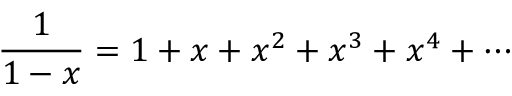Convert formula to latex. <formula><loc_0><loc_0><loc_500><loc_500>{ \frac { 1 } { 1 - x } } = 1 + x + x ^ { 2 } + x ^ { 3 } + x ^ { 4 } + \cdots</formula> 